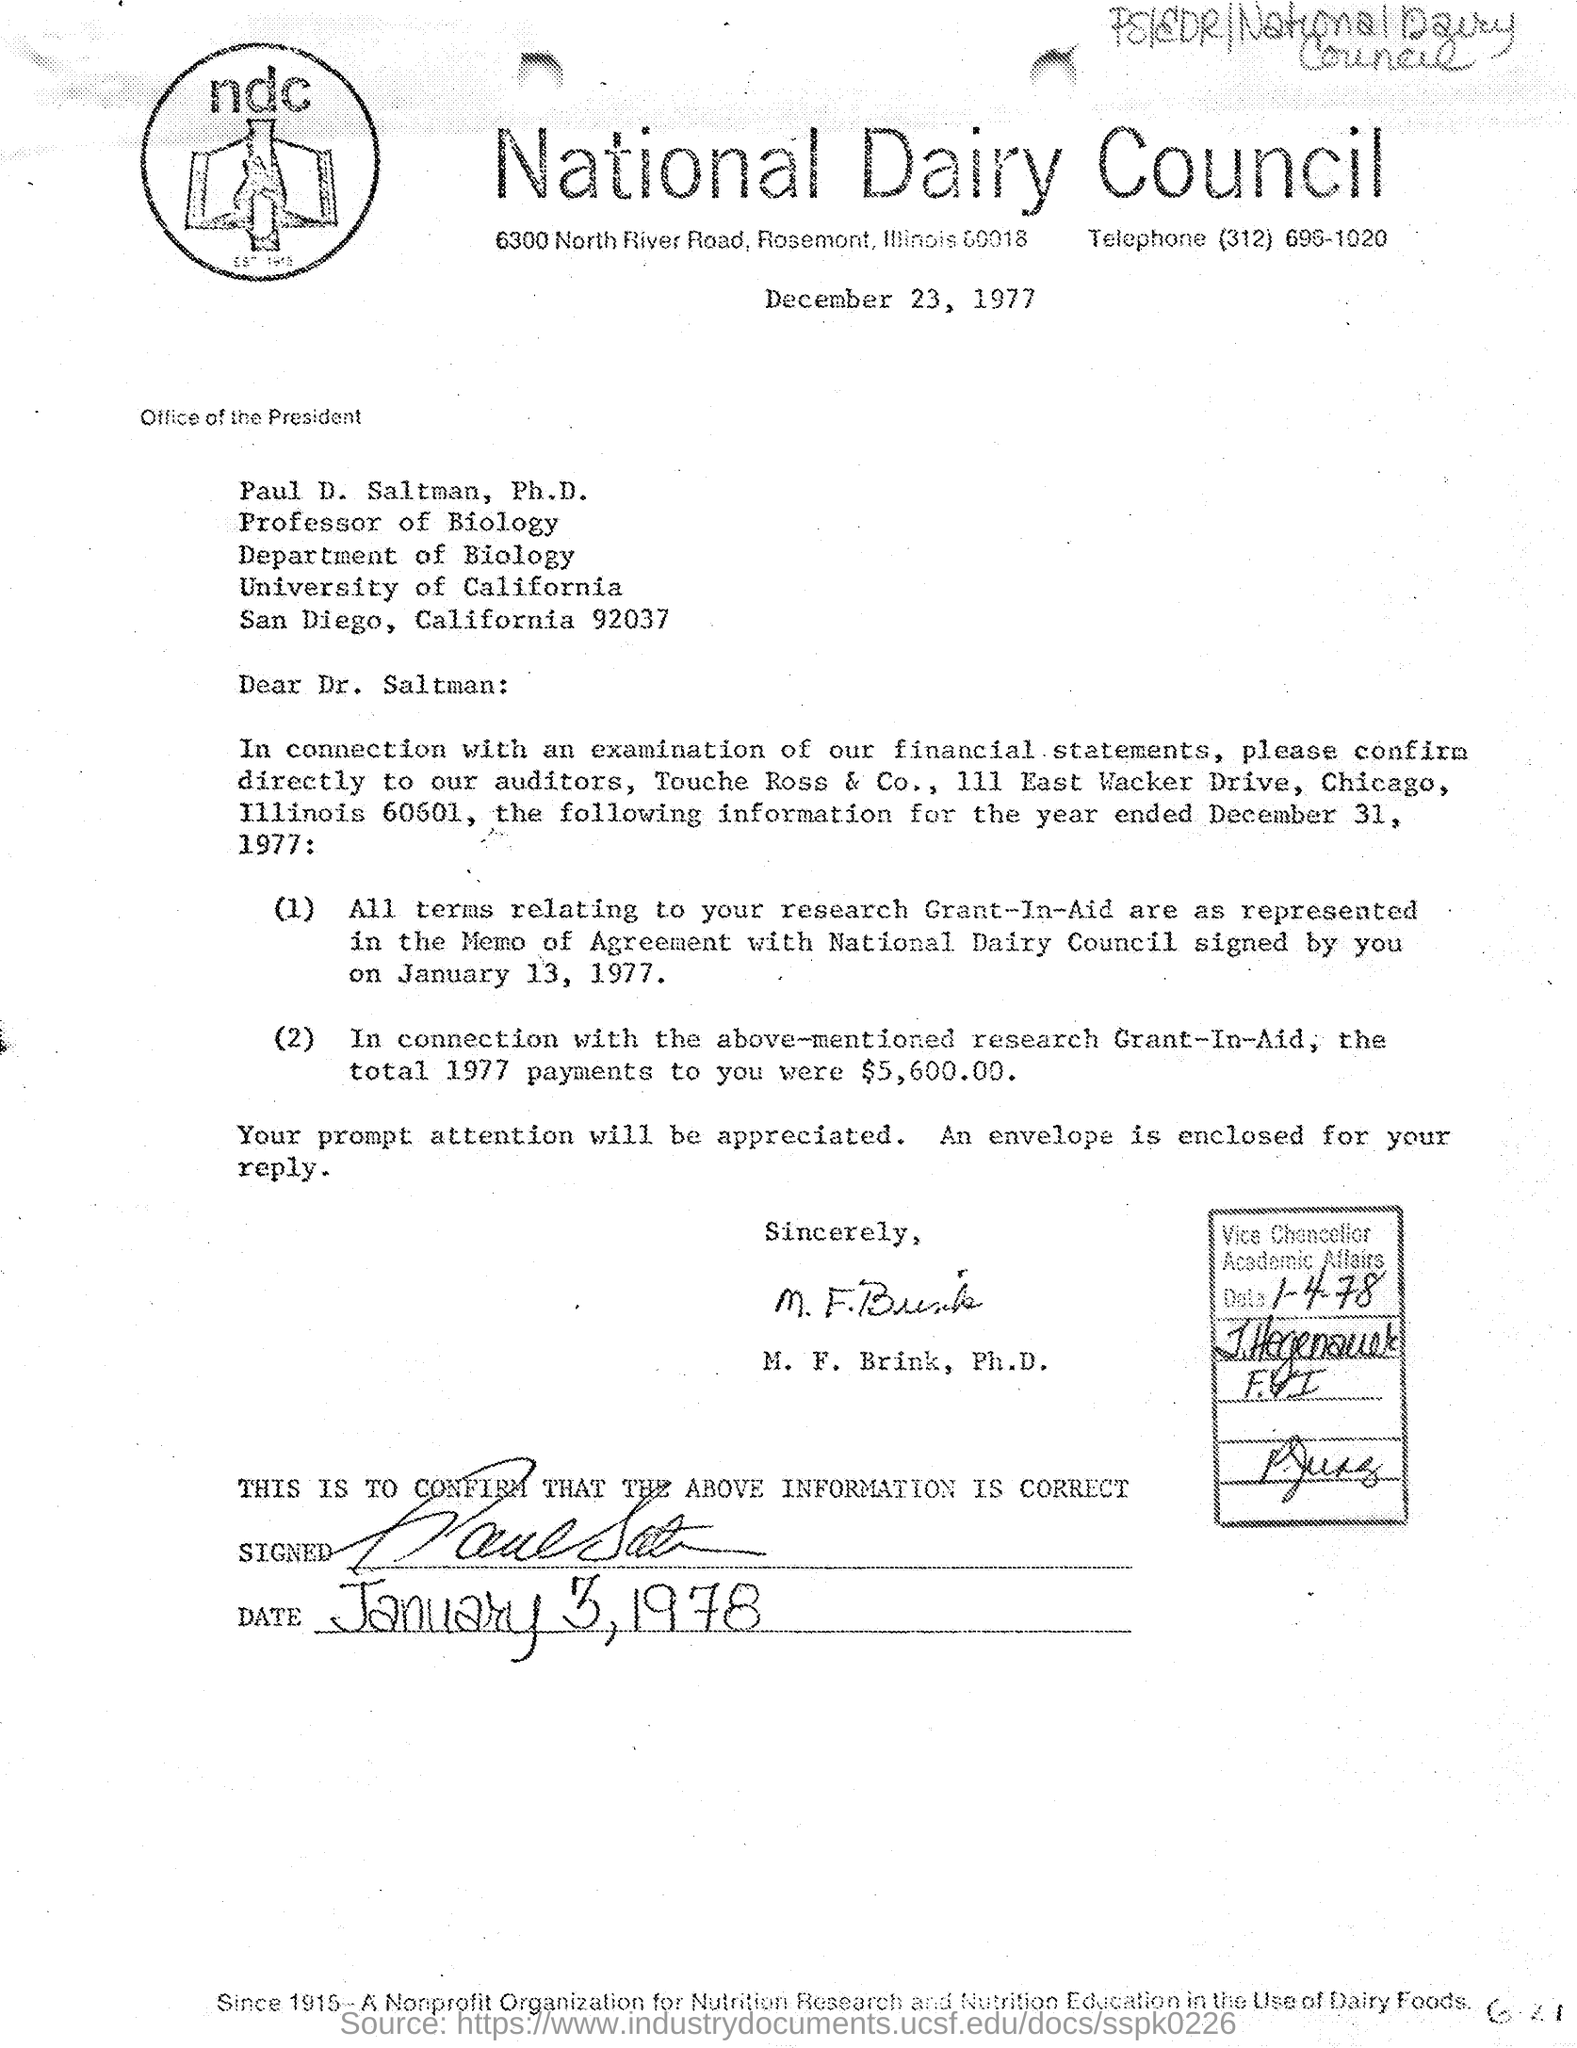What is the telephone number mentioned?
Offer a terse response. (312) 696-1020. To whom this letter is written
Keep it short and to the point. Paul D. Saltman, Ph.D. 